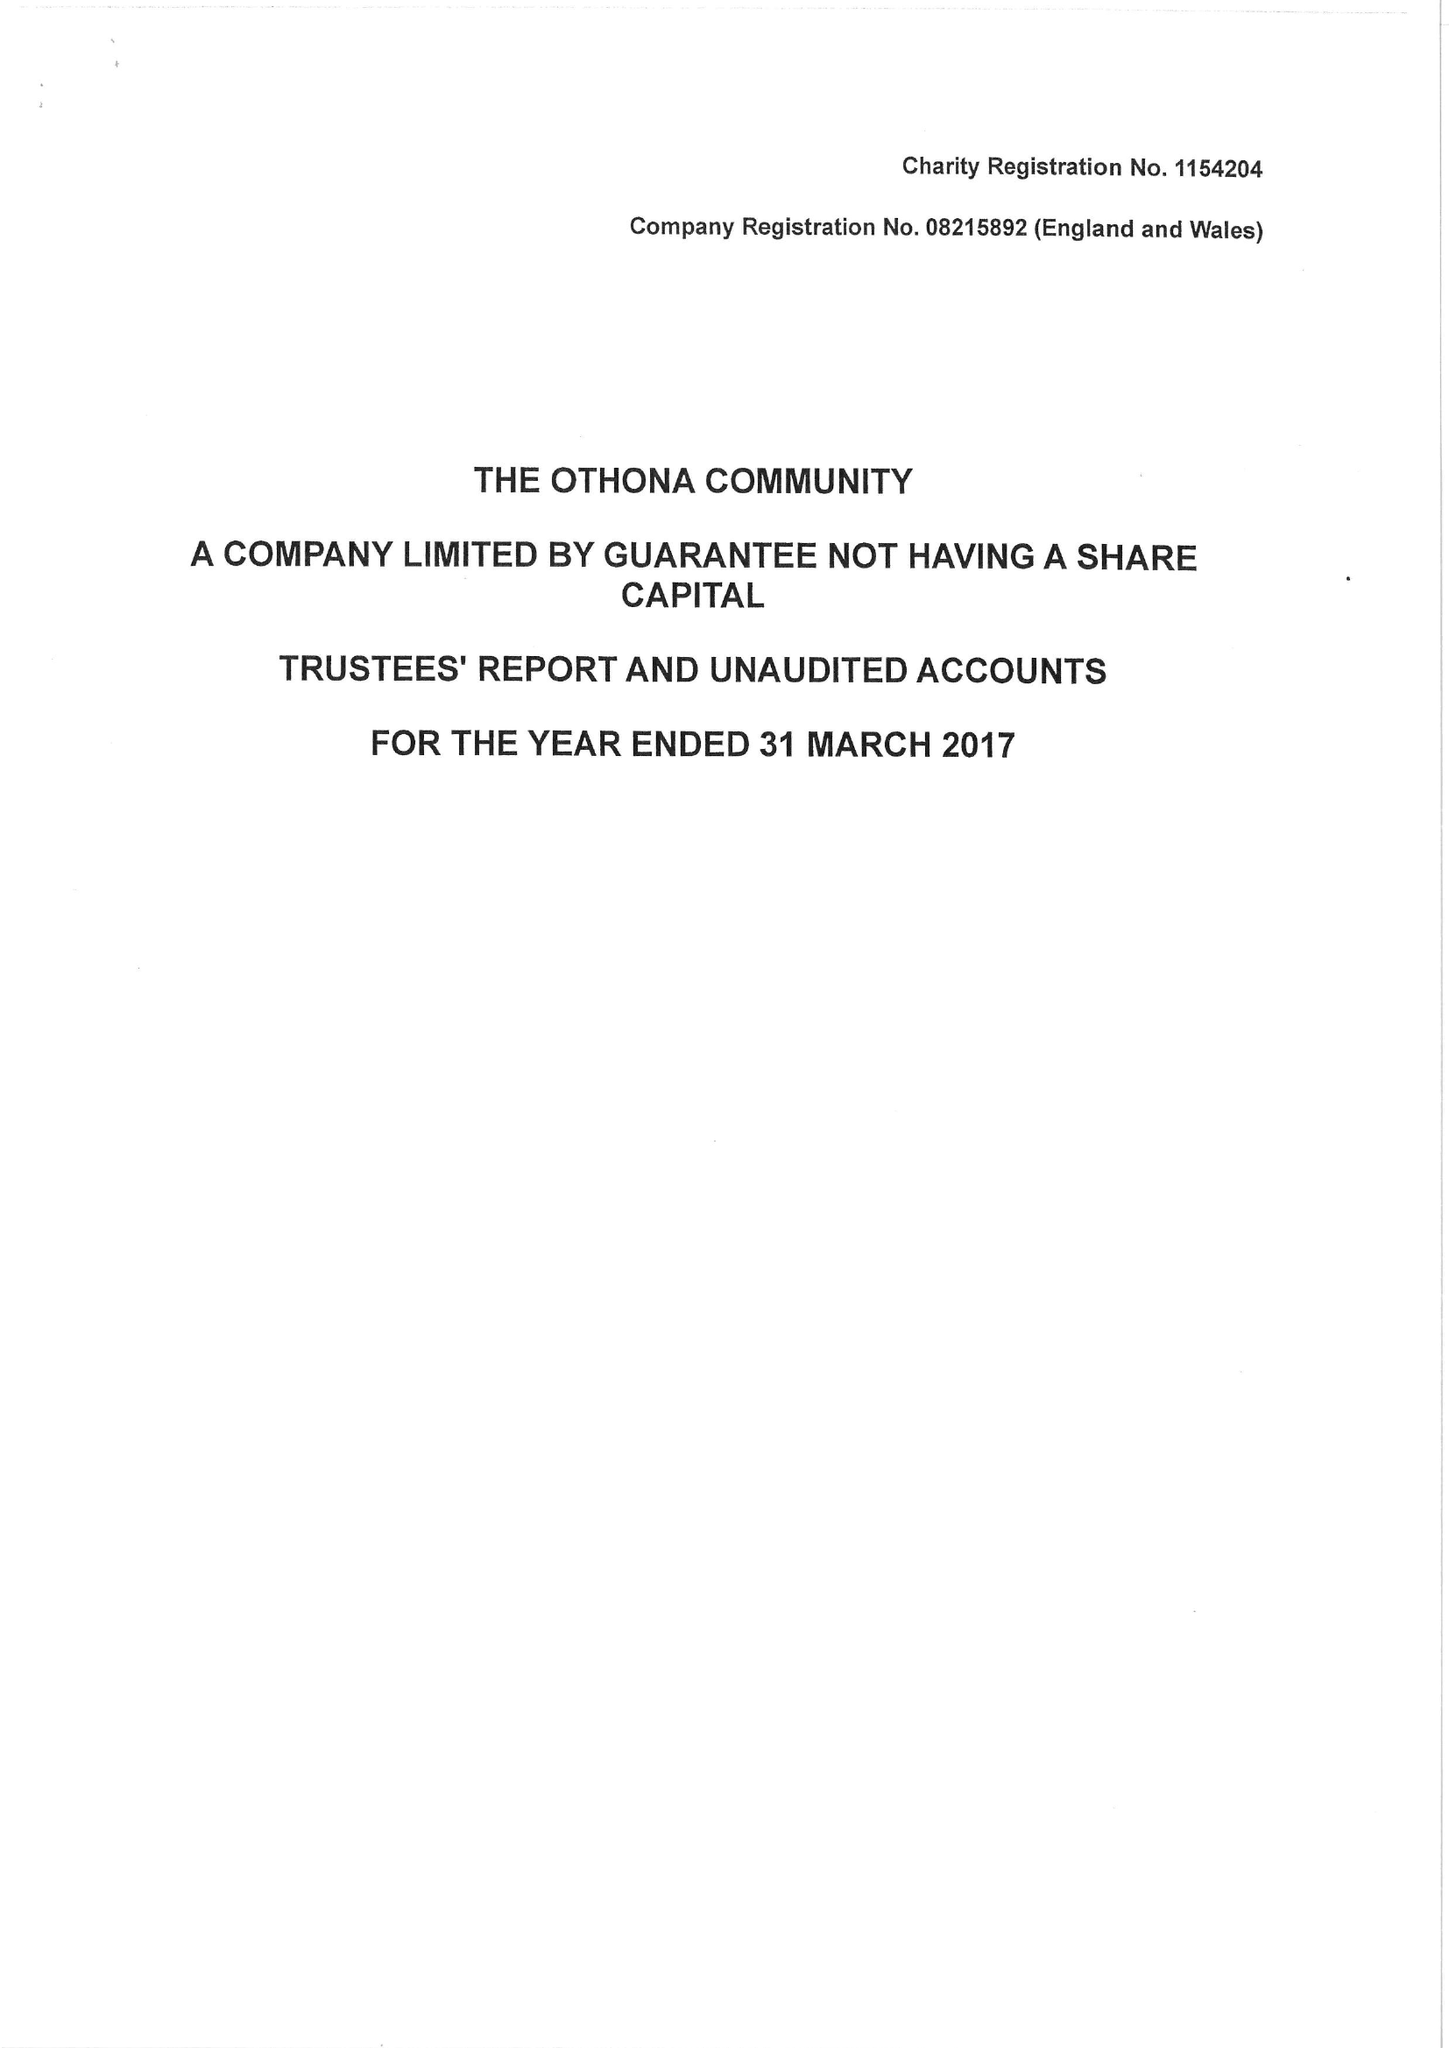What is the value for the spending_annually_in_british_pounds?
Answer the question using a single word or phrase. 293588.00 